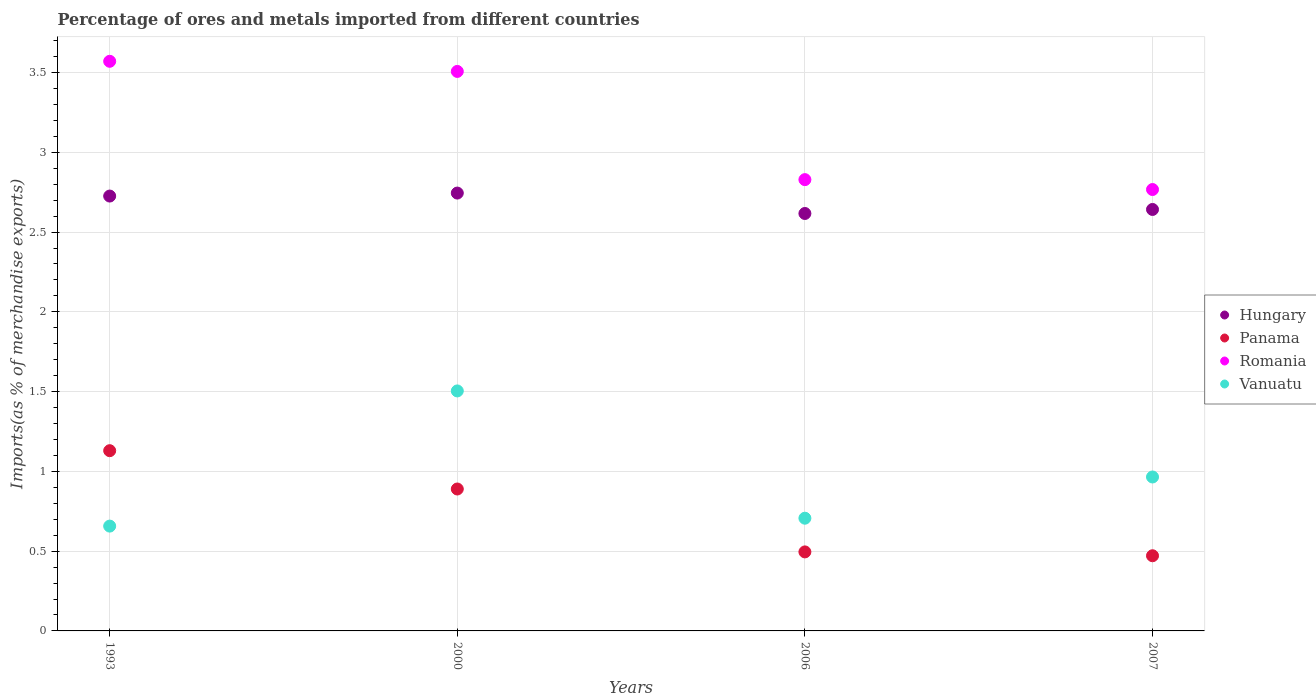How many different coloured dotlines are there?
Ensure brevity in your answer.  4. Is the number of dotlines equal to the number of legend labels?
Offer a terse response. Yes. What is the percentage of imports to different countries in Panama in 2006?
Ensure brevity in your answer.  0.5. Across all years, what is the maximum percentage of imports to different countries in Romania?
Offer a very short reply. 3.57. Across all years, what is the minimum percentage of imports to different countries in Vanuatu?
Provide a short and direct response. 0.66. In which year was the percentage of imports to different countries in Romania minimum?
Your answer should be compact. 2007. What is the total percentage of imports to different countries in Romania in the graph?
Your answer should be compact. 12.67. What is the difference between the percentage of imports to different countries in Hungary in 2000 and that in 2006?
Make the answer very short. 0.13. What is the difference between the percentage of imports to different countries in Hungary in 1993 and the percentage of imports to different countries in Panama in 2000?
Your answer should be very brief. 1.84. What is the average percentage of imports to different countries in Hungary per year?
Your response must be concise. 2.68. In the year 1993, what is the difference between the percentage of imports to different countries in Hungary and percentage of imports to different countries in Romania?
Your answer should be very brief. -0.84. In how many years, is the percentage of imports to different countries in Hungary greater than 2.1 %?
Keep it short and to the point. 4. What is the ratio of the percentage of imports to different countries in Panama in 1993 to that in 2007?
Your answer should be very brief. 2.4. Is the percentage of imports to different countries in Romania in 1993 less than that in 2006?
Give a very brief answer. No. Is the difference between the percentage of imports to different countries in Hungary in 2000 and 2006 greater than the difference between the percentage of imports to different countries in Romania in 2000 and 2006?
Make the answer very short. No. What is the difference between the highest and the second highest percentage of imports to different countries in Romania?
Provide a short and direct response. 0.06. What is the difference between the highest and the lowest percentage of imports to different countries in Hungary?
Give a very brief answer. 0.13. In how many years, is the percentage of imports to different countries in Hungary greater than the average percentage of imports to different countries in Hungary taken over all years?
Give a very brief answer. 2. Is it the case that in every year, the sum of the percentage of imports to different countries in Vanuatu and percentage of imports to different countries in Romania  is greater than the percentage of imports to different countries in Panama?
Provide a succinct answer. Yes. Is the percentage of imports to different countries in Panama strictly greater than the percentage of imports to different countries in Vanuatu over the years?
Provide a succinct answer. No. Are the values on the major ticks of Y-axis written in scientific E-notation?
Keep it short and to the point. No. How are the legend labels stacked?
Your answer should be very brief. Vertical. What is the title of the graph?
Provide a short and direct response. Percentage of ores and metals imported from different countries. Does "Bulgaria" appear as one of the legend labels in the graph?
Make the answer very short. No. What is the label or title of the Y-axis?
Provide a succinct answer. Imports(as % of merchandise exports). What is the Imports(as % of merchandise exports) of Hungary in 1993?
Offer a very short reply. 2.73. What is the Imports(as % of merchandise exports) of Panama in 1993?
Offer a terse response. 1.13. What is the Imports(as % of merchandise exports) of Romania in 1993?
Give a very brief answer. 3.57. What is the Imports(as % of merchandise exports) in Vanuatu in 1993?
Offer a very short reply. 0.66. What is the Imports(as % of merchandise exports) of Hungary in 2000?
Provide a short and direct response. 2.74. What is the Imports(as % of merchandise exports) in Panama in 2000?
Give a very brief answer. 0.89. What is the Imports(as % of merchandise exports) of Romania in 2000?
Give a very brief answer. 3.51. What is the Imports(as % of merchandise exports) of Vanuatu in 2000?
Your response must be concise. 1.5. What is the Imports(as % of merchandise exports) in Hungary in 2006?
Ensure brevity in your answer.  2.62. What is the Imports(as % of merchandise exports) of Panama in 2006?
Make the answer very short. 0.5. What is the Imports(as % of merchandise exports) of Romania in 2006?
Offer a terse response. 2.83. What is the Imports(as % of merchandise exports) in Vanuatu in 2006?
Your answer should be very brief. 0.71. What is the Imports(as % of merchandise exports) of Hungary in 2007?
Ensure brevity in your answer.  2.64. What is the Imports(as % of merchandise exports) of Panama in 2007?
Give a very brief answer. 0.47. What is the Imports(as % of merchandise exports) in Romania in 2007?
Offer a very short reply. 2.77. What is the Imports(as % of merchandise exports) in Vanuatu in 2007?
Give a very brief answer. 0.96. Across all years, what is the maximum Imports(as % of merchandise exports) in Hungary?
Offer a terse response. 2.74. Across all years, what is the maximum Imports(as % of merchandise exports) of Panama?
Your answer should be very brief. 1.13. Across all years, what is the maximum Imports(as % of merchandise exports) in Romania?
Your response must be concise. 3.57. Across all years, what is the maximum Imports(as % of merchandise exports) in Vanuatu?
Provide a succinct answer. 1.5. Across all years, what is the minimum Imports(as % of merchandise exports) in Hungary?
Your response must be concise. 2.62. Across all years, what is the minimum Imports(as % of merchandise exports) of Panama?
Give a very brief answer. 0.47. Across all years, what is the minimum Imports(as % of merchandise exports) of Romania?
Give a very brief answer. 2.77. Across all years, what is the minimum Imports(as % of merchandise exports) in Vanuatu?
Give a very brief answer. 0.66. What is the total Imports(as % of merchandise exports) in Hungary in the graph?
Keep it short and to the point. 10.73. What is the total Imports(as % of merchandise exports) of Panama in the graph?
Ensure brevity in your answer.  2.99. What is the total Imports(as % of merchandise exports) in Romania in the graph?
Keep it short and to the point. 12.67. What is the total Imports(as % of merchandise exports) in Vanuatu in the graph?
Provide a succinct answer. 3.83. What is the difference between the Imports(as % of merchandise exports) of Hungary in 1993 and that in 2000?
Offer a very short reply. -0.02. What is the difference between the Imports(as % of merchandise exports) in Panama in 1993 and that in 2000?
Provide a short and direct response. 0.24. What is the difference between the Imports(as % of merchandise exports) of Romania in 1993 and that in 2000?
Keep it short and to the point. 0.06. What is the difference between the Imports(as % of merchandise exports) in Vanuatu in 1993 and that in 2000?
Give a very brief answer. -0.85. What is the difference between the Imports(as % of merchandise exports) in Hungary in 1993 and that in 2006?
Your answer should be compact. 0.11. What is the difference between the Imports(as % of merchandise exports) in Panama in 1993 and that in 2006?
Offer a terse response. 0.63. What is the difference between the Imports(as % of merchandise exports) in Romania in 1993 and that in 2006?
Provide a short and direct response. 0.74. What is the difference between the Imports(as % of merchandise exports) in Vanuatu in 1993 and that in 2006?
Provide a short and direct response. -0.05. What is the difference between the Imports(as % of merchandise exports) in Hungary in 1993 and that in 2007?
Offer a terse response. 0.08. What is the difference between the Imports(as % of merchandise exports) of Panama in 1993 and that in 2007?
Your answer should be very brief. 0.66. What is the difference between the Imports(as % of merchandise exports) of Romania in 1993 and that in 2007?
Your answer should be compact. 0.8. What is the difference between the Imports(as % of merchandise exports) in Vanuatu in 1993 and that in 2007?
Ensure brevity in your answer.  -0.31. What is the difference between the Imports(as % of merchandise exports) in Hungary in 2000 and that in 2006?
Your answer should be very brief. 0.13. What is the difference between the Imports(as % of merchandise exports) in Panama in 2000 and that in 2006?
Make the answer very short. 0.39. What is the difference between the Imports(as % of merchandise exports) of Romania in 2000 and that in 2006?
Your answer should be compact. 0.68. What is the difference between the Imports(as % of merchandise exports) in Vanuatu in 2000 and that in 2006?
Give a very brief answer. 0.8. What is the difference between the Imports(as % of merchandise exports) in Hungary in 2000 and that in 2007?
Make the answer very short. 0.1. What is the difference between the Imports(as % of merchandise exports) of Panama in 2000 and that in 2007?
Keep it short and to the point. 0.42. What is the difference between the Imports(as % of merchandise exports) in Romania in 2000 and that in 2007?
Provide a succinct answer. 0.74. What is the difference between the Imports(as % of merchandise exports) of Vanuatu in 2000 and that in 2007?
Keep it short and to the point. 0.54. What is the difference between the Imports(as % of merchandise exports) in Hungary in 2006 and that in 2007?
Make the answer very short. -0.03. What is the difference between the Imports(as % of merchandise exports) of Panama in 2006 and that in 2007?
Your answer should be compact. 0.02. What is the difference between the Imports(as % of merchandise exports) of Romania in 2006 and that in 2007?
Your answer should be compact. 0.06. What is the difference between the Imports(as % of merchandise exports) in Vanuatu in 2006 and that in 2007?
Your answer should be very brief. -0.26. What is the difference between the Imports(as % of merchandise exports) in Hungary in 1993 and the Imports(as % of merchandise exports) in Panama in 2000?
Ensure brevity in your answer.  1.84. What is the difference between the Imports(as % of merchandise exports) of Hungary in 1993 and the Imports(as % of merchandise exports) of Romania in 2000?
Your answer should be very brief. -0.78. What is the difference between the Imports(as % of merchandise exports) of Hungary in 1993 and the Imports(as % of merchandise exports) of Vanuatu in 2000?
Ensure brevity in your answer.  1.22. What is the difference between the Imports(as % of merchandise exports) of Panama in 1993 and the Imports(as % of merchandise exports) of Romania in 2000?
Ensure brevity in your answer.  -2.38. What is the difference between the Imports(as % of merchandise exports) of Panama in 1993 and the Imports(as % of merchandise exports) of Vanuatu in 2000?
Provide a succinct answer. -0.37. What is the difference between the Imports(as % of merchandise exports) in Romania in 1993 and the Imports(as % of merchandise exports) in Vanuatu in 2000?
Offer a terse response. 2.07. What is the difference between the Imports(as % of merchandise exports) in Hungary in 1993 and the Imports(as % of merchandise exports) in Panama in 2006?
Your answer should be very brief. 2.23. What is the difference between the Imports(as % of merchandise exports) of Hungary in 1993 and the Imports(as % of merchandise exports) of Romania in 2006?
Offer a very short reply. -0.1. What is the difference between the Imports(as % of merchandise exports) of Hungary in 1993 and the Imports(as % of merchandise exports) of Vanuatu in 2006?
Your response must be concise. 2.02. What is the difference between the Imports(as % of merchandise exports) in Panama in 1993 and the Imports(as % of merchandise exports) in Romania in 2006?
Make the answer very short. -1.7. What is the difference between the Imports(as % of merchandise exports) in Panama in 1993 and the Imports(as % of merchandise exports) in Vanuatu in 2006?
Give a very brief answer. 0.42. What is the difference between the Imports(as % of merchandise exports) of Romania in 1993 and the Imports(as % of merchandise exports) of Vanuatu in 2006?
Provide a succinct answer. 2.86. What is the difference between the Imports(as % of merchandise exports) in Hungary in 1993 and the Imports(as % of merchandise exports) in Panama in 2007?
Give a very brief answer. 2.25. What is the difference between the Imports(as % of merchandise exports) of Hungary in 1993 and the Imports(as % of merchandise exports) of Romania in 2007?
Ensure brevity in your answer.  -0.04. What is the difference between the Imports(as % of merchandise exports) in Hungary in 1993 and the Imports(as % of merchandise exports) in Vanuatu in 2007?
Your response must be concise. 1.76. What is the difference between the Imports(as % of merchandise exports) of Panama in 1993 and the Imports(as % of merchandise exports) of Romania in 2007?
Provide a short and direct response. -1.64. What is the difference between the Imports(as % of merchandise exports) of Panama in 1993 and the Imports(as % of merchandise exports) of Vanuatu in 2007?
Ensure brevity in your answer.  0.16. What is the difference between the Imports(as % of merchandise exports) of Romania in 1993 and the Imports(as % of merchandise exports) of Vanuatu in 2007?
Ensure brevity in your answer.  2.61. What is the difference between the Imports(as % of merchandise exports) of Hungary in 2000 and the Imports(as % of merchandise exports) of Panama in 2006?
Offer a terse response. 2.25. What is the difference between the Imports(as % of merchandise exports) of Hungary in 2000 and the Imports(as % of merchandise exports) of Romania in 2006?
Your answer should be very brief. -0.08. What is the difference between the Imports(as % of merchandise exports) of Hungary in 2000 and the Imports(as % of merchandise exports) of Vanuatu in 2006?
Offer a terse response. 2.04. What is the difference between the Imports(as % of merchandise exports) of Panama in 2000 and the Imports(as % of merchandise exports) of Romania in 2006?
Offer a terse response. -1.94. What is the difference between the Imports(as % of merchandise exports) in Panama in 2000 and the Imports(as % of merchandise exports) in Vanuatu in 2006?
Offer a terse response. 0.18. What is the difference between the Imports(as % of merchandise exports) of Romania in 2000 and the Imports(as % of merchandise exports) of Vanuatu in 2006?
Ensure brevity in your answer.  2.8. What is the difference between the Imports(as % of merchandise exports) of Hungary in 2000 and the Imports(as % of merchandise exports) of Panama in 2007?
Your response must be concise. 2.27. What is the difference between the Imports(as % of merchandise exports) in Hungary in 2000 and the Imports(as % of merchandise exports) in Romania in 2007?
Your answer should be very brief. -0.02. What is the difference between the Imports(as % of merchandise exports) in Hungary in 2000 and the Imports(as % of merchandise exports) in Vanuatu in 2007?
Your answer should be compact. 1.78. What is the difference between the Imports(as % of merchandise exports) of Panama in 2000 and the Imports(as % of merchandise exports) of Romania in 2007?
Provide a succinct answer. -1.88. What is the difference between the Imports(as % of merchandise exports) in Panama in 2000 and the Imports(as % of merchandise exports) in Vanuatu in 2007?
Your answer should be very brief. -0.08. What is the difference between the Imports(as % of merchandise exports) in Romania in 2000 and the Imports(as % of merchandise exports) in Vanuatu in 2007?
Make the answer very short. 2.54. What is the difference between the Imports(as % of merchandise exports) of Hungary in 2006 and the Imports(as % of merchandise exports) of Panama in 2007?
Offer a terse response. 2.15. What is the difference between the Imports(as % of merchandise exports) of Hungary in 2006 and the Imports(as % of merchandise exports) of Romania in 2007?
Offer a terse response. -0.15. What is the difference between the Imports(as % of merchandise exports) in Hungary in 2006 and the Imports(as % of merchandise exports) in Vanuatu in 2007?
Keep it short and to the point. 1.65. What is the difference between the Imports(as % of merchandise exports) of Panama in 2006 and the Imports(as % of merchandise exports) of Romania in 2007?
Provide a succinct answer. -2.27. What is the difference between the Imports(as % of merchandise exports) in Panama in 2006 and the Imports(as % of merchandise exports) in Vanuatu in 2007?
Your answer should be very brief. -0.47. What is the difference between the Imports(as % of merchandise exports) of Romania in 2006 and the Imports(as % of merchandise exports) of Vanuatu in 2007?
Provide a short and direct response. 1.86. What is the average Imports(as % of merchandise exports) in Hungary per year?
Ensure brevity in your answer.  2.68. What is the average Imports(as % of merchandise exports) of Panama per year?
Give a very brief answer. 0.75. What is the average Imports(as % of merchandise exports) in Romania per year?
Give a very brief answer. 3.17. What is the average Imports(as % of merchandise exports) in Vanuatu per year?
Give a very brief answer. 0.96. In the year 1993, what is the difference between the Imports(as % of merchandise exports) of Hungary and Imports(as % of merchandise exports) of Panama?
Your response must be concise. 1.6. In the year 1993, what is the difference between the Imports(as % of merchandise exports) of Hungary and Imports(as % of merchandise exports) of Romania?
Provide a short and direct response. -0.84. In the year 1993, what is the difference between the Imports(as % of merchandise exports) in Hungary and Imports(as % of merchandise exports) in Vanuatu?
Offer a very short reply. 2.07. In the year 1993, what is the difference between the Imports(as % of merchandise exports) in Panama and Imports(as % of merchandise exports) in Romania?
Your response must be concise. -2.44. In the year 1993, what is the difference between the Imports(as % of merchandise exports) in Panama and Imports(as % of merchandise exports) in Vanuatu?
Ensure brevity in your answer.  0.47. In the year 1993, what is the difference between the Imports(as % of merchandise exports) in Romania and Imports(as % of merchandise exports) in Vanuatu?
Give a very brief answer. 2.91. In the year 2000, what is the difference between the Imports(as % of merchandise exports) of Hungary and Imports(as % of merchandise exports) of Panama?
Give a very brief answer. 1.85. In the year 2000, what is the difference between the Imports(as % of merchandise exports) in Hungary and Imports(as % of merchandise exports) in Romania?
Provide a succinct answer. -0.76. In the year 2000, what is the difference between the Imports(as % of merchandise exports) in Hungary and Imports(as % of merchandise exports) in Vanuatu?
Give a very brief answer. 1.24. In the year 2000, what is the difference between the Imports(as % of merchandise exports) in Panama and Imports(as % of merchandise exports) in Romania?
Provide a succinct answer. -2.62. In the year 2000, what is the difference between the Imports(as % of merchandise exports) in Panama and Imports(as % of merchandise exports) in Vanuatu?
Ensure brevity in your answer.  -0.61. In the year 2000, what is the difference between the Imports(as % of merchandise exports) in Romania and Imports(as % of merchandise exports) in Vanuatu?
Make the answer very short. 2. In the year 2006, what is the difference between the Imports(as % of merchandise exports) of Hungary and Imports(as % of merchandise exports) of Panama?
Keep it short and to the point. 2.12. In the year 2006, what is the difference between the Imports(as % of merchandise exports) in Hungary and Imports(as % of merchandise exports) in Romania?
Your response must be concise. -0.21. In the year 2006, what is the difference between the Imports(as % of merchandise exports) in Hungary and Imports(as % of merchandise exports) in Vanuatu?
Your answer should be compact. 1.91. In the year 2006, what is the difference between the Imports(as % of merchandise exports) of Panama and Imports(as % of merchandise exports) of Romania?
Make the answer very short. -2.33. In the year 2006, what is the difference between the Imports(as % of merchandise exports) of Panama and Imports(as % of merchandise exports) of Vanuatu?
Give a very brief answer. -0.21. In the year 2006, what is the difference between the Imports(as % of merchandise exports) of Romania and Imports(as % of merchandise exports) of Vanuatu?
Keep it short and to the point. 2.12. In the year 2007, what is the difference between the Imports(as % of merchandise exports) of Hungary and Imports(as % of merchandise exports) of Panama?
Your answer should be very brief. 2.17. In the year 2007, what is the difference between the Imports(as % of merchandise exports) in Hungary and Imports(as % of merchandise exports) in Romania?
Offer a very short reply. -0.12. In the year 2007, what is the difference between the Imports(as % of merchandise exports) of Hungary and Imports(as % of merchandise exports) of Vanuatu?
Give a very brief answer. 1.68. In the year 2007, what is the difference between the Imports(as % of merchandise exports) of Panama and Imports(as % of merchandise exports) of Romania?
Offer a terse response. -2.3. In the year 2007, what is the difference between the Imports(as % of merchandise exports) in Panama and Imports(as % of merchandise exports) in Vanuatu?
Provide a short and direct response. -0.49. In the year 2007, what is the difference between the Imports(as % of merchandise exports) in Romania and Imports(as % of merchandise exports) in Vanuatu?
Offer a very short reply. 1.8. What is the ratio of the Imports(as % of merchandise exports) of Hungary in 1993 to that in 2000?
Your response must be concise. 0.99. What is the ratio of the Imports(as % of merchandise exports) in Panama in 1993 to that in 2000?
Your answer should be very brief. 1.27. What is the ratio of the Imports(as % of merchandise exports) in Romania in 1993 to that in 2000?
Your answer should be compact. 1.02. What is the ratio of the Imports(as % of merchandise exports) of Vanuatu in 1993 to that in 2000?
Keep it short and to the point. 0.44. What is the ratio of the Imports(as % of merchandise exports) of Hungary in 1993 to that in 2006?
Your response must be concise. 1.04. What is the ratio of the Imports(as % of merchandise exports) in Panama in 1993 to that in 2006?
Offer a very short reply. 2.28. What is the ratio of the Imports(as % of merchandise exports) in Romania in 1993 to that in 2006?
Make the answer very short. 1.26. What is the ratio of the Imports(as % of merchandise exports) of Vanuatu in 1993 to that in 2006?
Keep it short and to the point. 0.93. What is the ratio of the Imports(as % of merchandise exports) in Hungary in 1993 to that in 2007?
Offer a very short reply. 1.03. What is the ratio of the Imports(as % of merchandise exports) in Panama in 1993 to that in 2007?
Your answer should be compact. 2.4. What is the ratio of the Imports(as % of merchandise exports) in Romania in 1993 to that in 2007?
Your answer should be very brief. 1.29. What is the ratio of the Imports(as % of merchandise exports) of Vanuatu in 1993 to that in 2007?
Your response must be concise. 0.68. What is the ratio of the Imports(as % of merchandise exports) in Hungary in 2000 to that in 2006?
Provide a succinct answer. 1.05. What is the ratio of the Imports(as % of merchandise exports) of Panama in 2000 to that in 2006?
Offer a very short reply. 1.8. What is the ratio of the Imports(as % of merchandise exports) of Romania in 2000 to that in 2006?
Provide a short and direct response. 1.24. What is the ratio of the Imports(as % of merchandise exports) in Vanuatu in 2000 to that in 2006?
Keep it short and to the point. 2.13. What is the ratio of the Imports(as % of merchandise exports) in Hungary in 2000 to that in 2007?
Provide a succinct answer. 1.04. What is the ratio of the Imports(as % of merchandise exports) of Panama in 2000 to that in 2007?
Make the answer very short. 1.89. What is the ratio of the Imports(as % of merchandise exports) in Romania in 2000 to that in 2007?
Offer a very short reply. 1.27. What is the ratio of the Imports(as % of merchandise exports) in Vanuatu in 2000 to that in 2007?
Your answer should be very brief. 1.56. What is the ratio of the Imports(as % of merchandise exports) in Panama in 2006 to that in 2007?
Keep it short and to the point. 1.05. What is the ratio of the Imports(as % of merchandise exports) in Romania in 2006 to that in 2007?
Keep it short and to the point. 1.02. What is the ratio of the Imports(as % of merchandise exports) of Vanuatu in 2006 to that in 2007?
Make the answer very short. 0.73. What is the difference between the highest and the second highest Imports(as % of merchandise exports) of Hungary?
Your answer should be very brief. 0.02. What is the difference between the highest and the second highest Imports(as % of merchandise exports) of Panama?
Offer a terse response. 0.24. What is the difference between the highest and the second highest Imports(as % of merchandise exports) in Romania?
Provide a succinct answer. 0.06. What is the difference between the highest and the second highest Imports(as % of merchandise exports) in Vanuatu?
Your response must be concise. 0.54. What is the difference between the highest and the lowest Imports(as % of merchandise exports) in Hungary?
Offer a terse response. 0.13. What is the difference between the highest and the lowest Imports(as % of merchandise exports) of Panama?
Provide a short and direct response. 0.66. What is the difference between the highest and the lowest Imports(as % of merchandise exports) in Romania?
Provide a short and direct response. 0.8. What is the difference between the highest and the lowest Imports(as % of merchandise exports) of Vanuatu?
Ensure brevity in your answer.  0.85. 